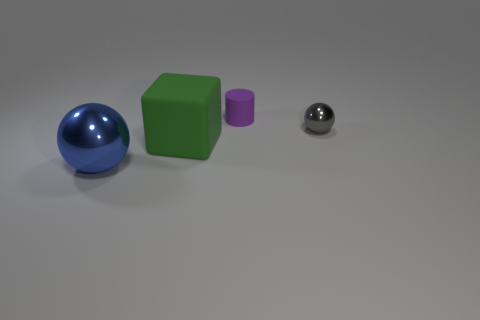The purple rubber thing has what size?
Ensure brevity in your answer.  Small. What number of tiny things are rubber blocks or purple cubes?
Keep it short and to the point. 0. There is another object that is the same size as the gray metal thing; what is its color?
Your answer should be compact. Purple. How many other things are there of the same shape as the tiny matte object?
Provide a succinct answer. 0. Is there a small purple cylinder made of the same material as the tiny gray object?
Provide a short and direct response. No. Is the ball that is behind the blue object made of the same material as the green thing on the left side of the purple matte thing?
Your answer should be compact. No. What number of big cyan spheres are there?
Give a very brief answer. 0. The tiny thing that is in front of the tiny purple cylinder has what shape?
Ensure brevity in your answer.  Sphere. There is a shiny object behind the blue shiny object; does it have the same shape as the matte object that is on the left side of the small purple rubber object?
Make the answer very short. No. How many large spheres are on the left side of the big blue sphere?
Offer a very short reply. 0. 